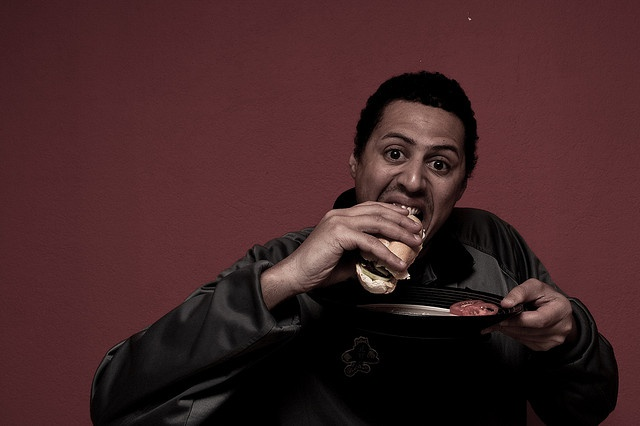Describe the objects in this image and their specific colors. I can see people in black, maroon, gray, and brown tones and sandwich in black, maroon, tan, and brown tones in this image. 